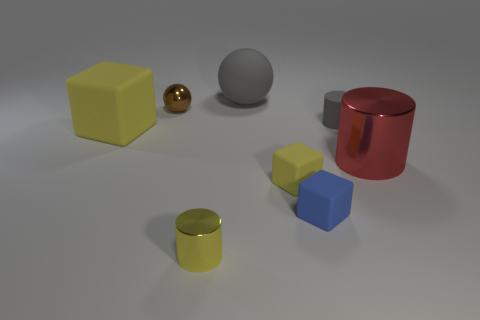Are there more things than big red metal objects?
Your response must be concise. Yes. There is a small block that is in front of the tiny yellow rubber cube; are there any shiny objects that are to the right of it?
Give a very brief answer. Yes. There is a big thing that is the same shape as the small yellow matte object; what is its color?
Give a very brief answer. Yellow. What color is the ball that is the same material as the small yellow cylinder?
Make the answer very short. Brown. There is a yellow rubber cube that is in front of the large thing that is on the left side of the big gray rubber ball; is there a yellow cube behind it?
Provide a succinct answer. Yes. Are there fewer small shiny objects in front of the large rubber cube than things that are right of the small metal cylinder?
Make the answer very short. Yes. How many gray objects have the same material as the brown thing?
Provide a succinct answer. 0. There is a yellow cylinder; does it have the same size as the gray thing behind the rubber cylinder?
Make the answer very short. No. There is a cylinder that is the same color as the large block; what is it made of?
Ensure brevity in your answer.  Metal. What is the size of the object behind the metal thing that is behind the large thing right of the large matte sphere?
Your response must be concise. Large. 